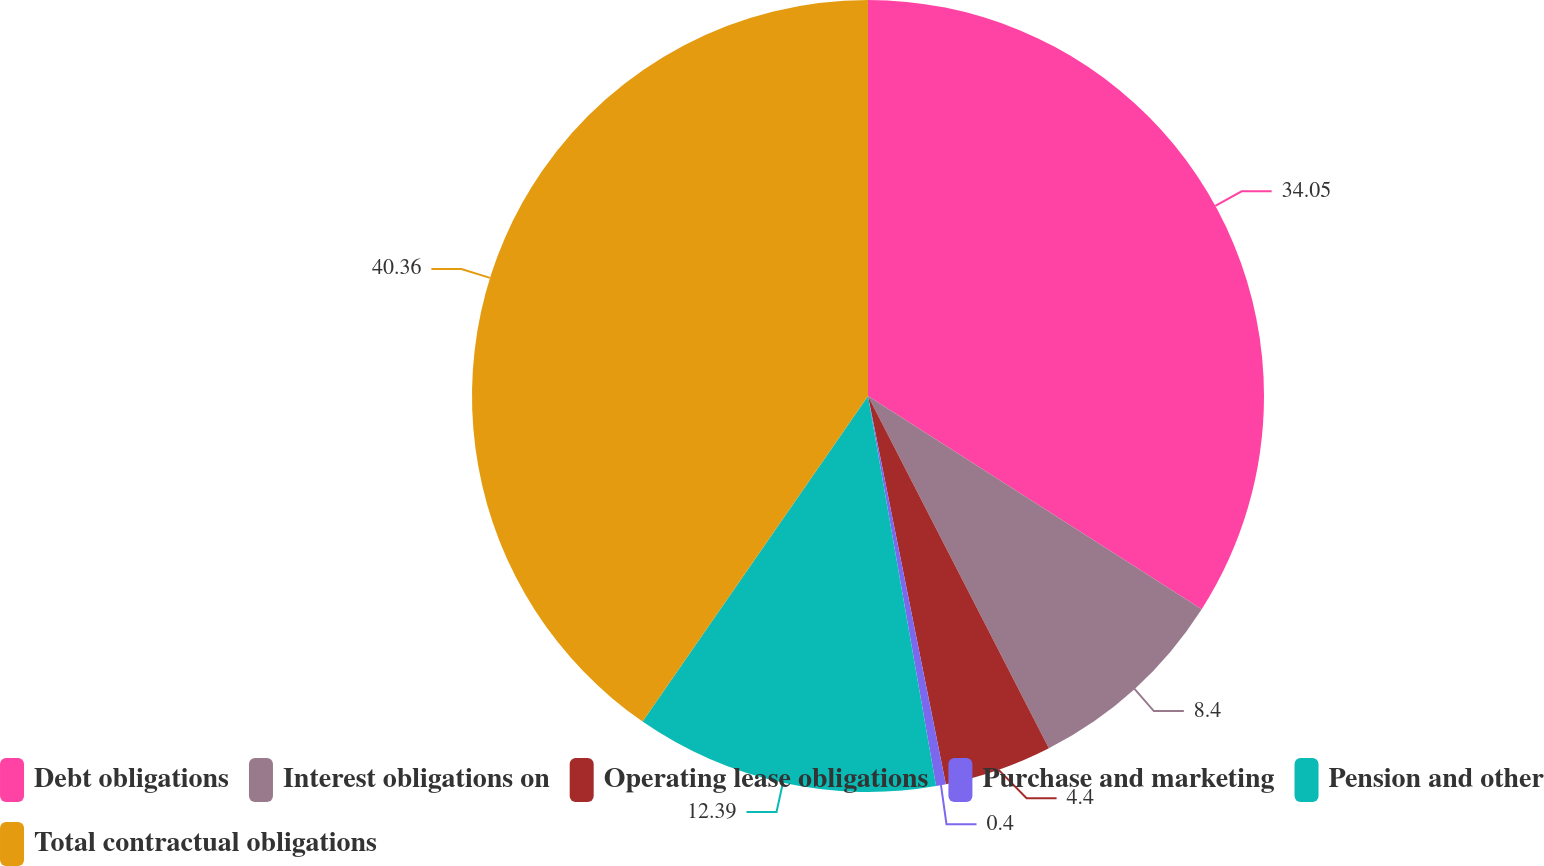<chart> <loc_0><loc_0><loc_500><loc_500><pie_chart><fcel>Debt obligations<fcel>Interest obligations on<fcel>Operating lease obligations<fcel>Purchase and marketing<fcel>Pension and other<fcel>Total contractual obligations<nl><fcel>34.05%<fcel>8.4%<fcel>4.4%<fcel>0.4%<fcel>12.39%<fcel>40.36%<nl></chart> 